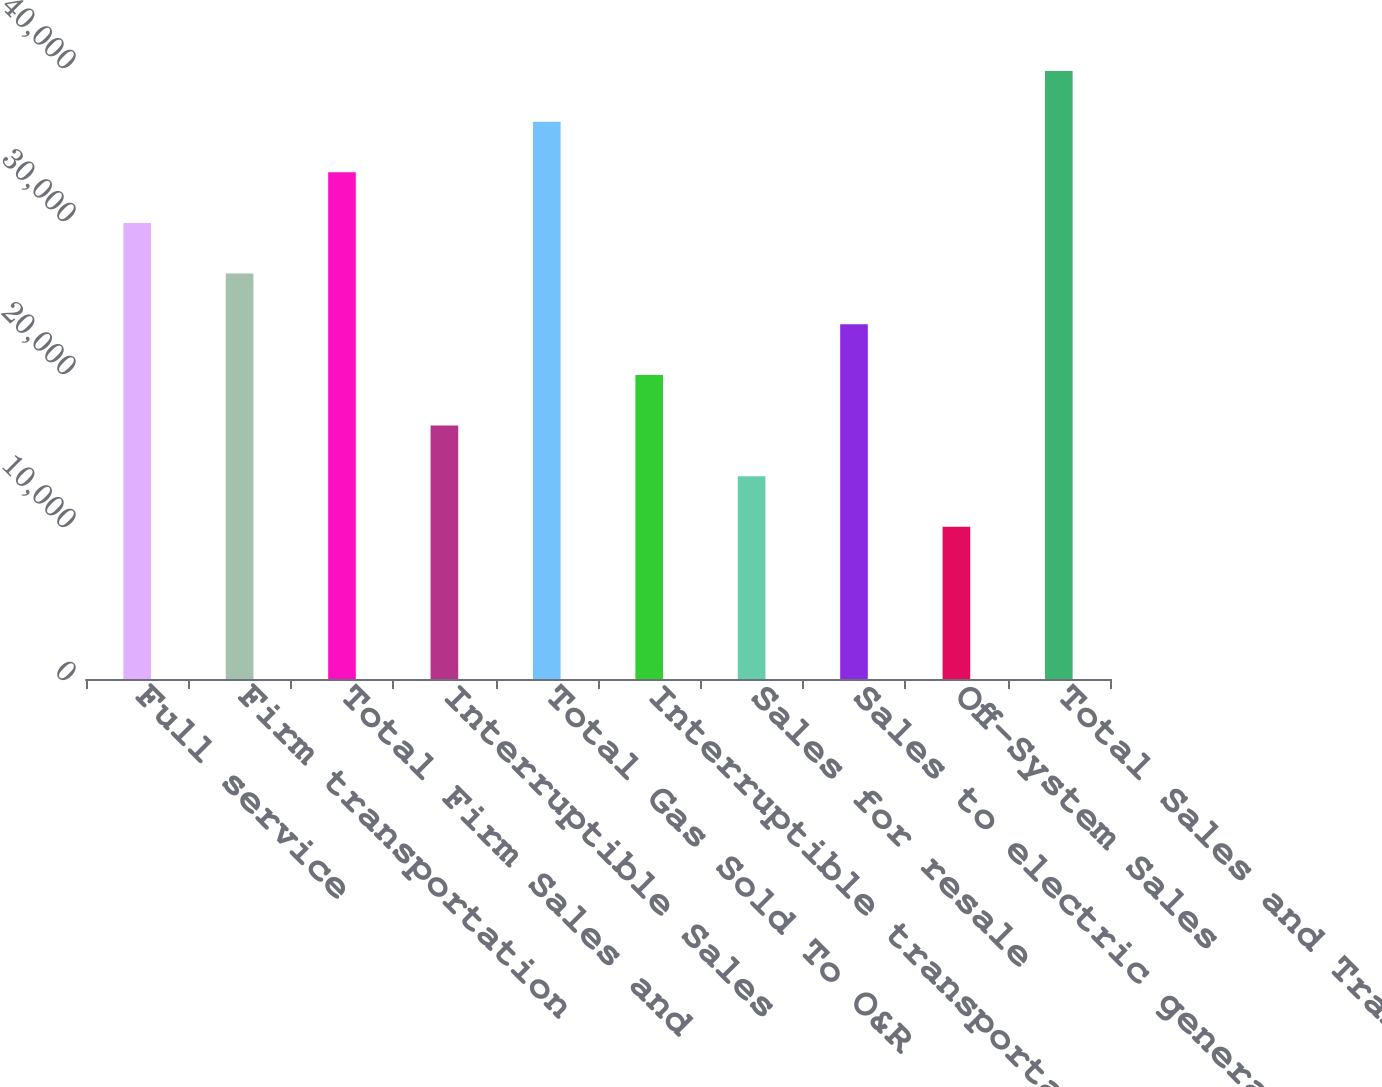Convert chart to OTSL. <chart><loc_0><loc_0><loc_500><loc_500><bar_chart><fcel>Full service<fcel>Firm transportation<fcel>Total Firm Sales and<fcel>Interruptible Sales<fcel>Total Gas Sold To O&R<fcel>Interruptible transportation<fcel>Sales for resale<fcel>Sales to electric generating<fcel>Off-System Sales<fcel>Total Sales and Transportation<nl><fcel>29806.5<fcel>26496<fcel>33117<fcel>16564.5<fcel>36427.5<fcel>19875<fcel>13254<fcel>23185.5<fcel>9943.5<fcel>39738<nl></chart> 